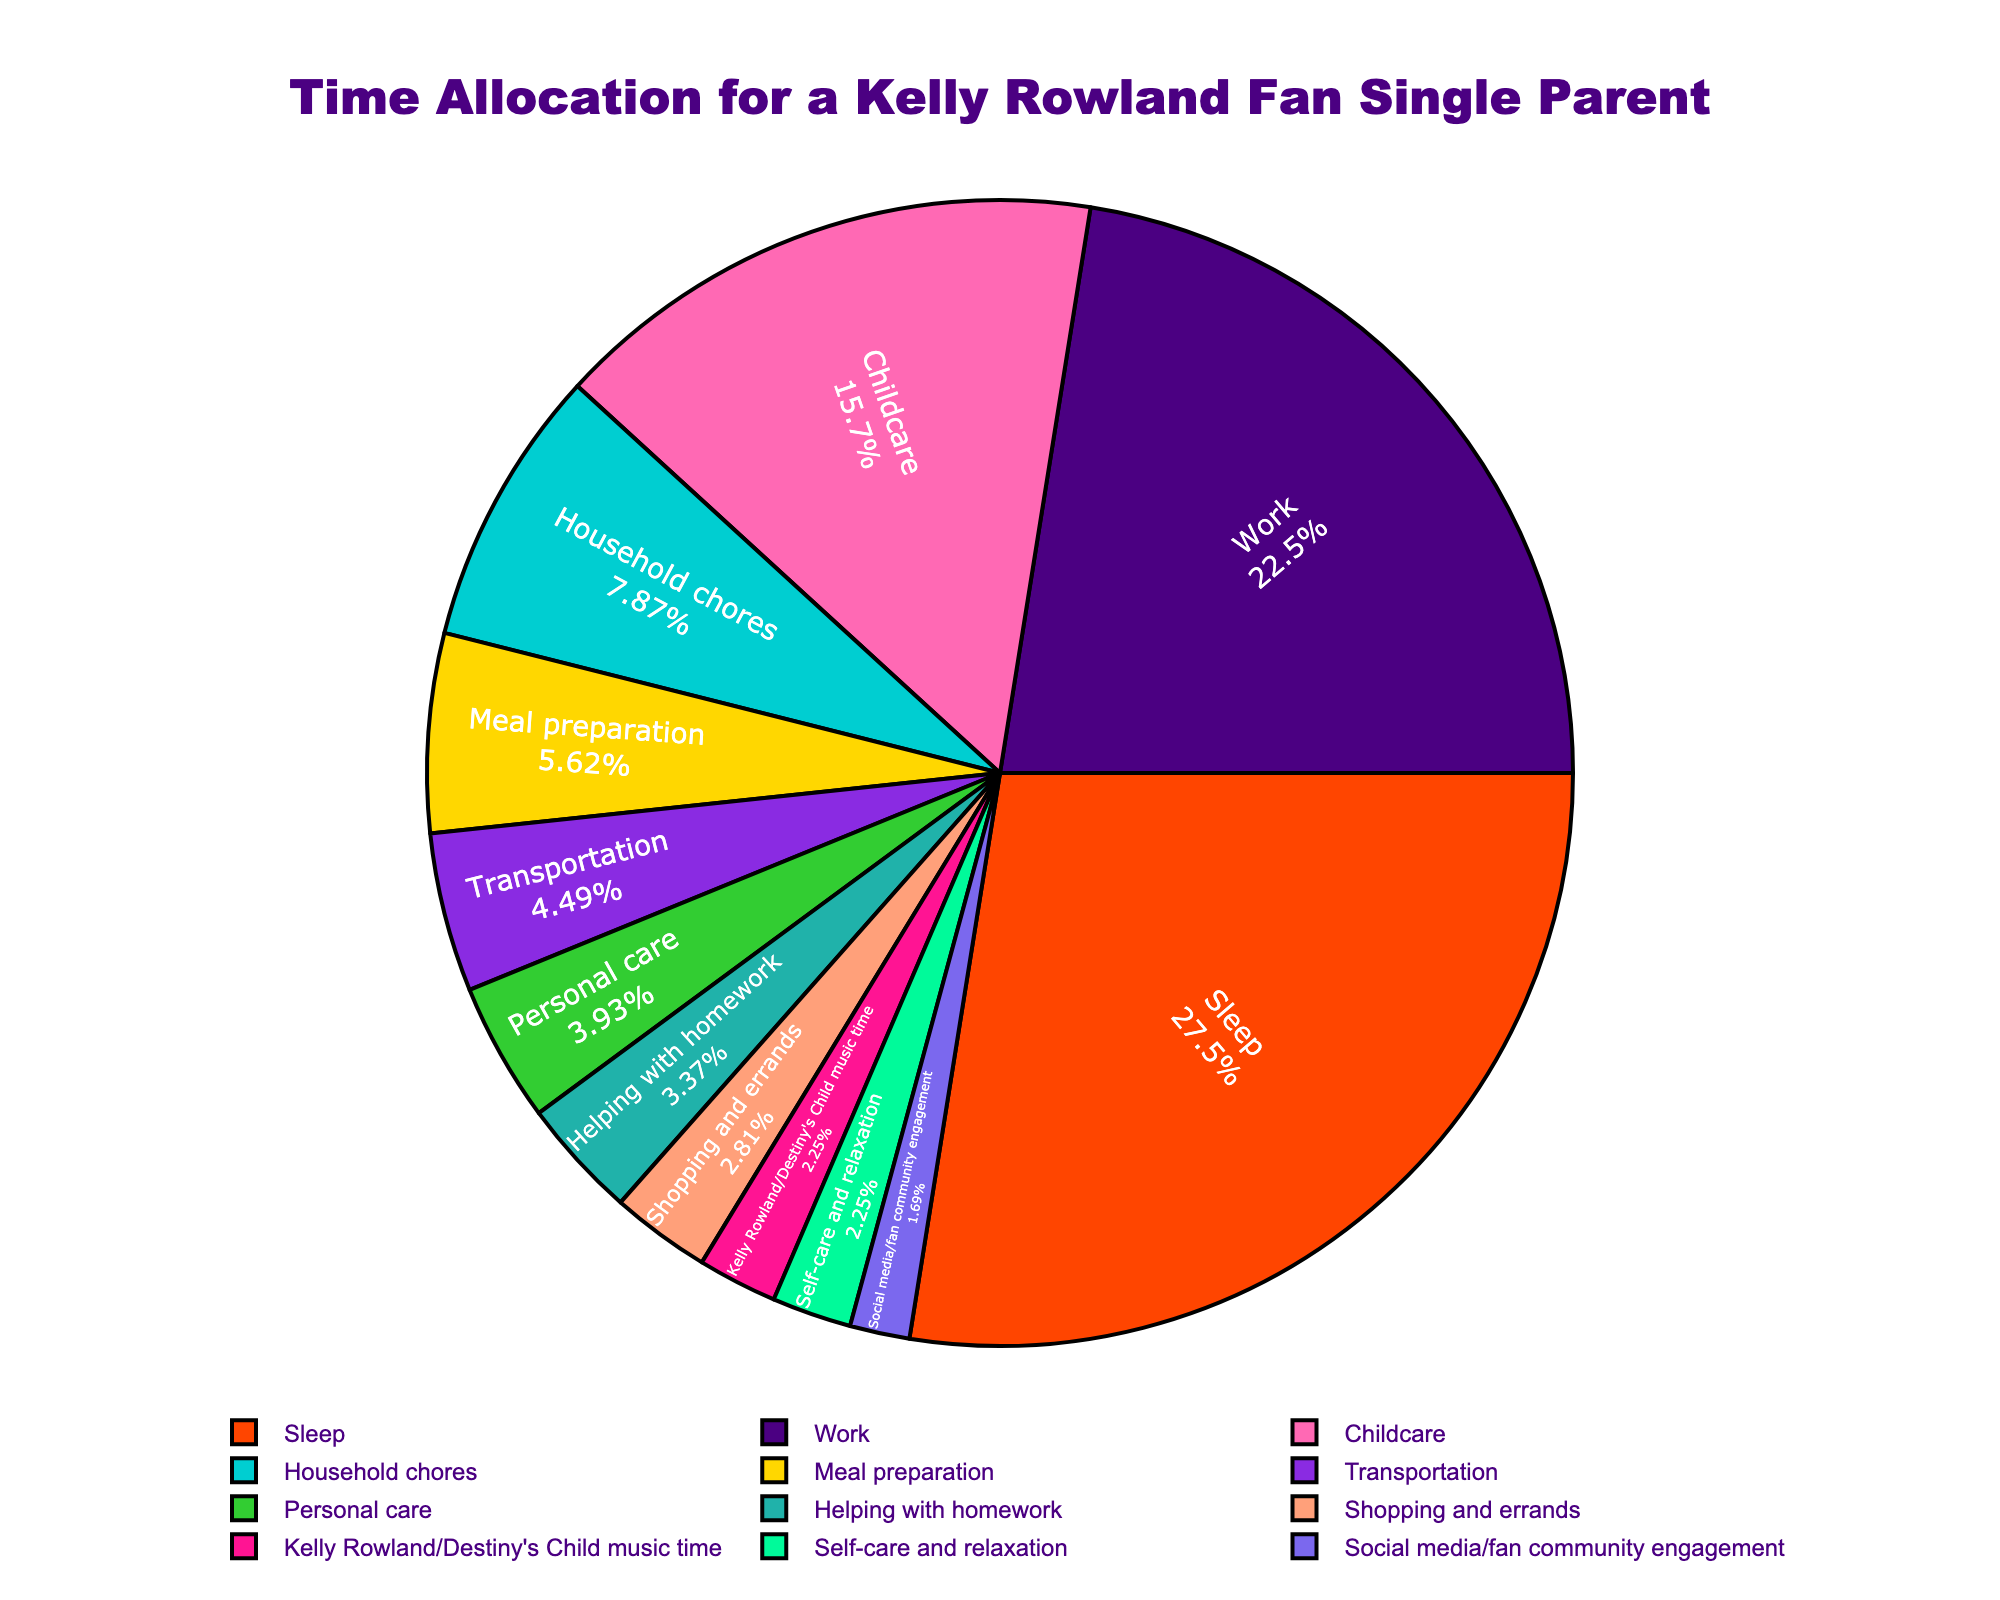What activity occupies the largest portion of time per week? By looking at the segments of the pie chart, we can observe that the largest section is labeled "Sleep." Therefore, sleep occupies the largest portion of time per week.
Answer: Sleep How many hours per week are spent on personal care and self-care and relaxation combined? Find the segments labeled "Personal care" and "Self-care and relaxation." Personal care is 7 hours and self-care and relaxation is 4 hours. Adding these together, 7 + 4 = 11 hours per week.
Answer: 11 Which activity takes up more time: meal preparation or helping with homework? Compare the sizes and labels of the sections corresponding to "Meal preparation" and "Helping with homework." Meal preparation is 10 hours per week, while helping with homework is 6 hours per week. Therefore, meal preparation takes up more time.
Answer: Meal preparation What percentage of time is dedicated to listening to Kelly Rowland/Destiny's Child music and engaging with the fan community combined? Find the segments labeled "Kelly Rowland/Destiny's Child music time" (4 hours) and "Social media/fan community engagement" (3 hours). Together they total 7 hours. To calculate the percentage, first, find the total number of hours per week. Summing all hours = 174. Thus, 7/174 ≈ 4.02%.
Answer: ~4.02% Are there any activities that take up exactly the same amount of time? By inspecting the size and labels of the segments, compare the values to see if any match exactly. In this chart, no two activities take up exactly the same amount of time.
Answer: No What is the combined percentage of time spent on work, transportation, and shopping and errands? Identify the "Work" (40 hours), "Transportation" (8 hours), and "Shopping and errands" (5 hours) segments. Their combined time is 53 hours. Calculate the percentage: 53/174 ≈ 30.46%.
Answer: ~30.46% Which activity has the smallest time allocation and what color represents it? The smallest segment in the pie chart is "Social media/fan community engagement." This segment is represented in the color green.
Answer: Social media/fan community engagement, green By how many hours does the time spent on work exceed the time spent on sleep? The segments for "Work" and "Sleep" show 40 hours and 49 hours respectively. Calculate the difference: 49 - 40 = 9 hours. Therefore, sleep exceeds work by 9 hours.
Answer: 9 What is the ratio of time spent on household chores to the time spent on social media/fan community engagement? Identify the segments labeled "Household chores" (14 hours) and "Social media/fan community engagement" (3 hours). Calculate the ratio: 14/3 ≈ 4.67.
Answer: 4.67 